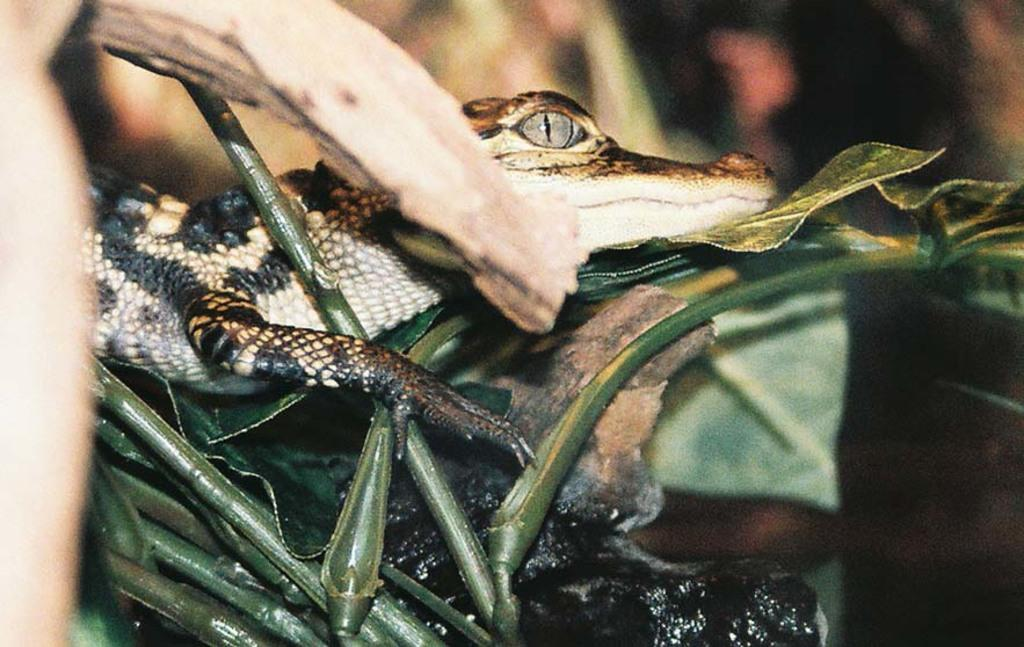What type of animal is in the image? There is a baby crocodile in the image. Where is the baby crocodile located? The baby crocodile is on a leaf. What can be seen at the bottom of the image? There are stems at the bottom of the image. What is the purpose of the board in the image? There is no board present in the image. 